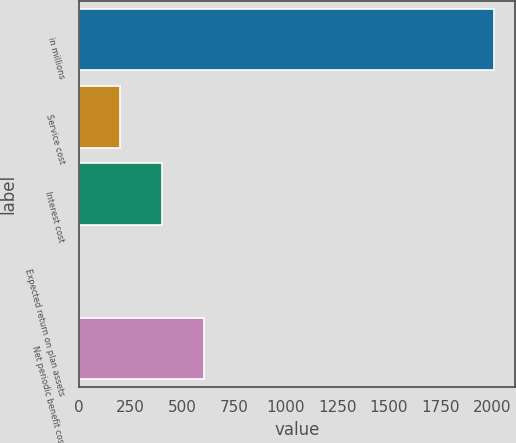Convert chart. <chart><loc_0><loc_0><loc_500><loc_500><bar_chart><fcel>in millions<fcel>Service cost<fcel>Interest cost<fcel>Expected return on plan assets<fcel>Net periodic benefit cost<nl><fcel>2010<fcel>201.36<fcel>402.32<fcel>0.4<fcel>603.28<nl></chart> 